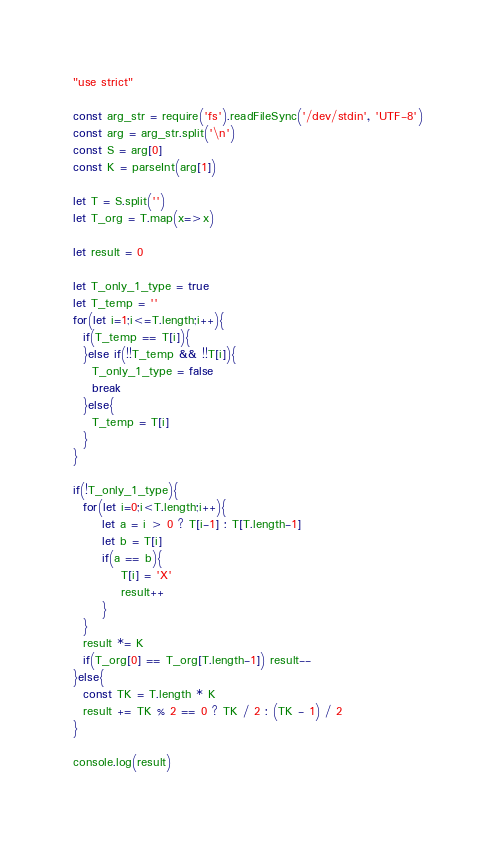Convert code to text. <code><loc_0><loc_0><loc_500><loc_500><_JavaScript_>"use strict"

const arg_str = require('fs').readFileSync('/dev/stdin', 'UTF-8')
const arg = arg_str.split('\n')
const S = arg[0]
const K = parseInt(arg[1])

let T = S.split('')
let T_org = T.map(x=>x)

let result = 0

let T_only_1_type = true
let T_temp = ''
for(let i=1;i<=T.length;i++){
  if(T_temp == T[i]){
  }else if(!!T_temp && !!T[i]){
    T_only_1_type = false
    break
  }else{
    T_temp = T[i]
  }
}

if(!T_only_1_type){
  for(let i=0;i<T.length;i++){
      let a = i > 0 ? T[i-1] : T[T.length-1]
      let b = T[i]
      if(a == b){
          T[i] = 'X'
          result++
      }
  }
  result *= K
  if(T_org[0] == T_org[T.length-1]) result--
}else{
  const TK = T.length * K
  result += TK % 2 == 0 ? TK / 2 : (TK - 1) / 2
}

console.log(result)</code> 